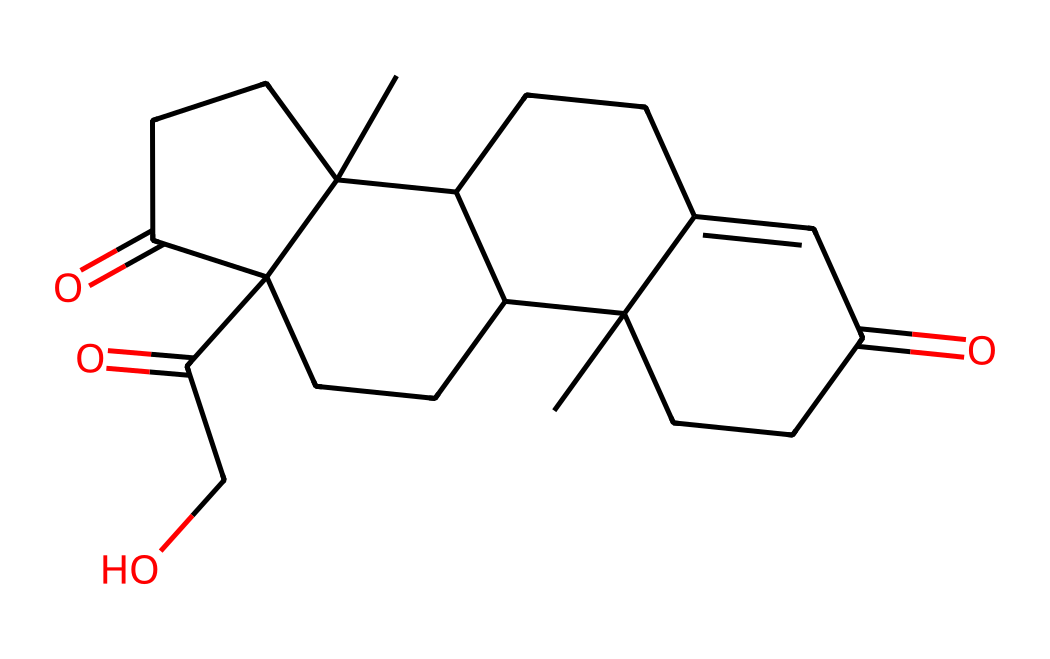What is the common name of this compound? The provided SMILES corresponds to cortisone, which is a well-known anti-inflammatory steroid.
Answer: cortisone How many carbon atoms are present in cortisone? By examining the SMILES representation, we can count the number of carbon atoms, which is indicated by the "C" in the structure. There are 21 carbon atoms in this compound.
Answer: 21 Does cortisone contain any chiral centers? To identify chiral centers, we look for carbon atoms bonded to four different groups. In the SMILES structure, there are multiple carbon atoms connected to different substituents, establishing several chiral centers.
Answer: yes What is the number of oxygen atoms in cortisone? The SMILES includes "O" letters which represent oxygen atoms. By counting them, there are 5 oxygen atoms in the structure of cortisone.
Answer: 5 What type of functional groups are present in cortisone? The structure indicates the presence of ketones (C=O) and hydroxyl (–OH) groups, which are characteristic functional groups in this particular steroid.
Answer: ketone and hydroxyl What is the significance of the double bonds in cortisone? The double bonds, indicated by "=" in the SMILES, affect the compound's overall structure and stereochemistry, impacting its biological activity and interaction with receptors.
Answer: affect activity How many rings are present in the structure of cortisone? The SMILES representation suggests a fused ring system typically observed in steroids. After analyzing the structure, we identify 4 interconnected rings.
Answer: 4 